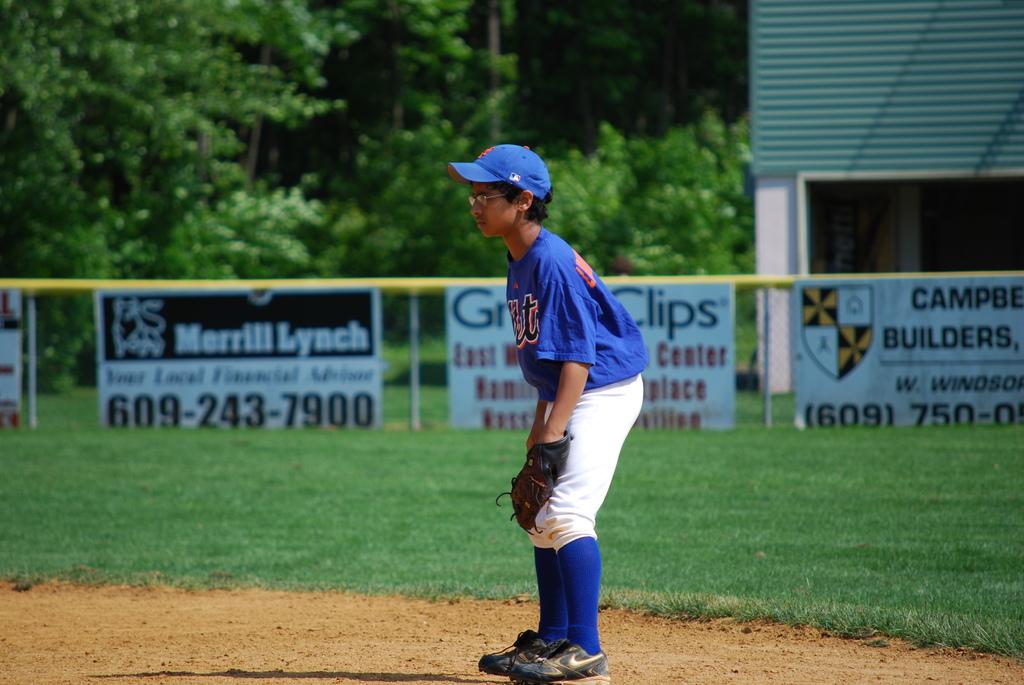Which company has the number 609-243-7900?
Give a very brief answer. Merrill lynch. 